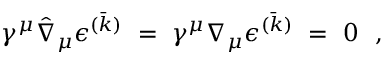<formula> <loc_0><loc_0><loc_500><loc_500>\gamma ^ { \mu } \hat { \nabla } _ { \mu } \epsilon ^ { ( \bar { k } ) } = \gamma ^ { \mu } \nabla _ { \mu } \epsilon ^ { ( \bar { k } ) } = 0 \ \ ,</formula> 